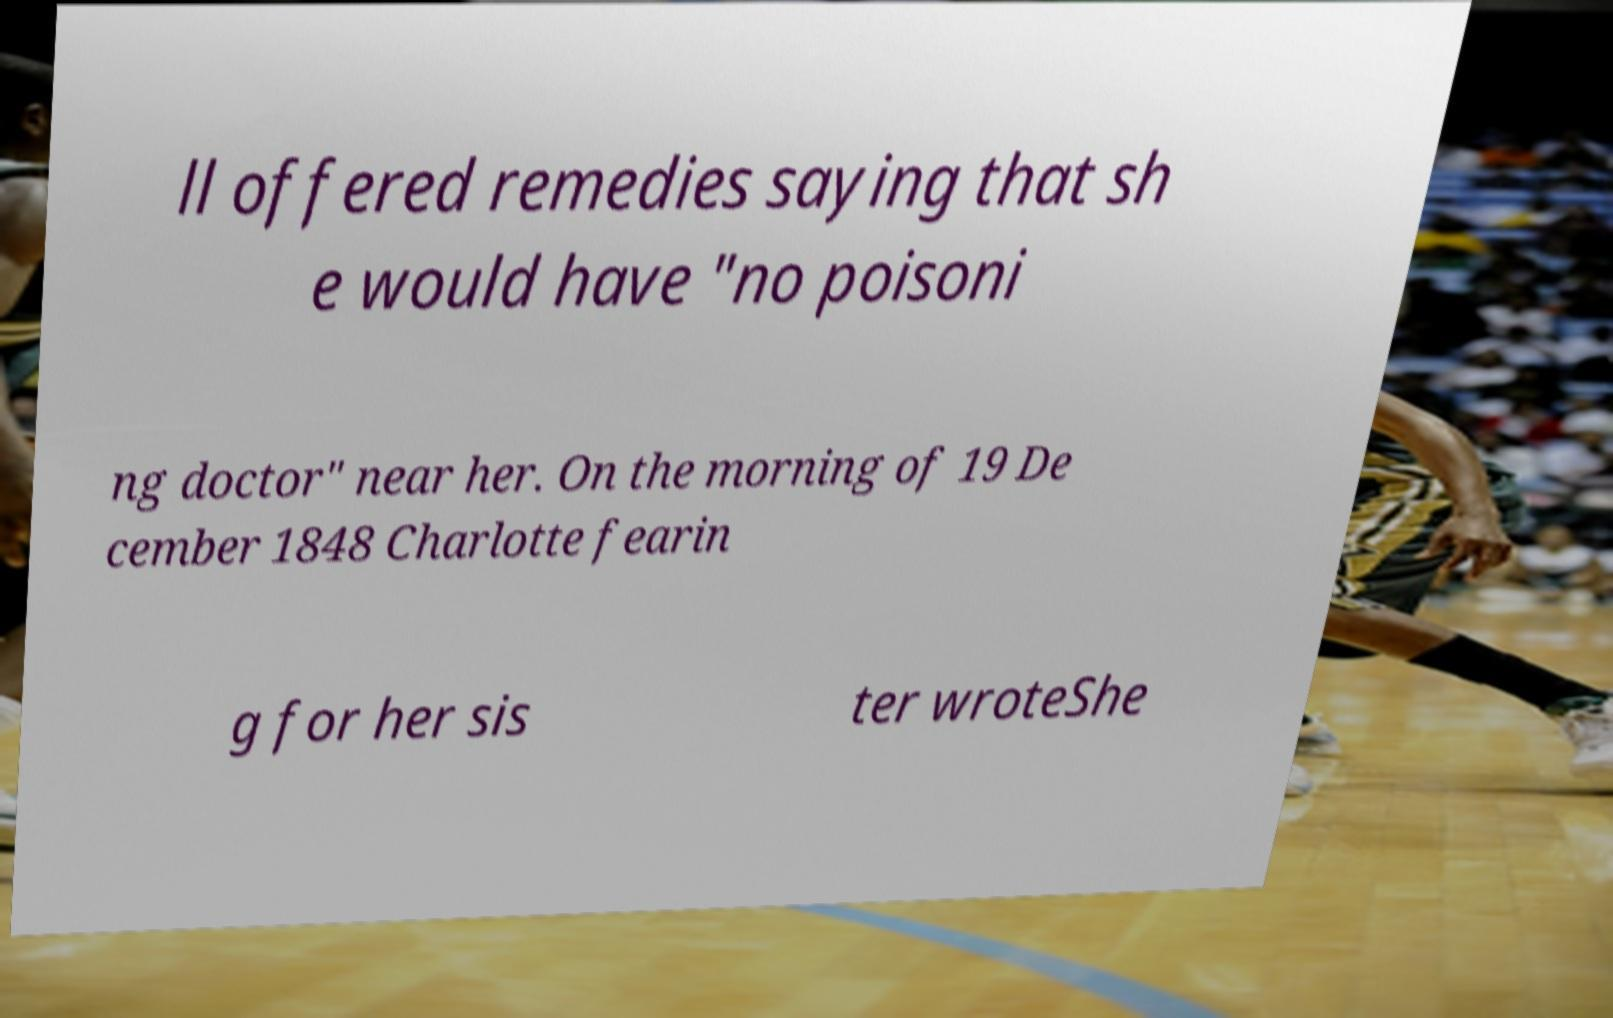Could you assist in decoding the text presented in this image and type it out clearly? ll offered remedies saying that sh e would have "no poisoni ng doctor" near her. On the morning of 19 De cember 1848 Charlotte fearin g for her sis ter wroteShe 